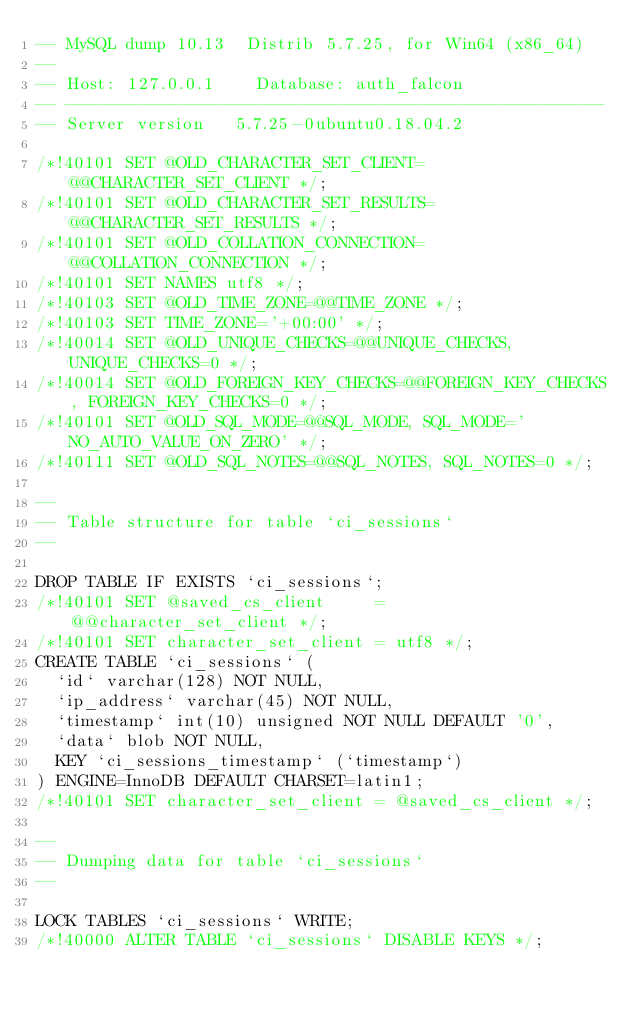Convert code to text. <code><loc_0><loc_0><loc_500><loc_500><_SQL_>-- MySQL dump 10.13  Distrib 5.7.25, for Win64 (x86_64)
--
-- Host: 127.0.0.1    Database: auth_falcon
-- ------------------------------------------------------
-- Server version	5.7.25-0ubuntu0.18.04.2

/*!40101 SET @OLD_CHARACTER_SET_CLIENT=@@CHARACTER_SET_CLIENT */;
/*!40101 SET @OLD_CHARACTER_SET_RESULTS=@@CHARACTER_SET_RESULTS */;
/*!40101 SET @OLD_COLLATION_CONNECTION=@@COLLATION_CONNECTION */;
/*!40101 SET NAMES utf8 */;
/*!40103 SET @OLD_TIME_ZONE=@@TIME_ZONE */;
/*!40103 SET TIME_ZONE='+00:00' */;
/*!40014 SET @OLD_UNIQUE_CHECKS=@@UNIQUE_CHECKS, UNIQUE_CHECKS=0 */;
/*!40014 SET @OLD_FOREIGN_KEY_CHECKS=@@FOREIGN_KEY_CHECKS, FOREIGN_KEY_CHECKS=0 */;
/*!40101 SET @OLD_SQL_MODE=@@SQL_MODE, SQL_MODE='NO_AUTO_VALUE_ON_ZERO' */;
/*!40111 SET @OLD_SQL_NOTES=@@SQL_NOTES, SQL_NOTES=0 */;

--
-- Table structure for table `ci_sessions`
--

DROP TABLE IF EXISTS `ci_sessions`;
/*!40101 SET @saved_cs_client     = @@character_set_client */;
/*!40101 SET character_set_client = utf8 */;
CREATE TABLE `ci_sessions` (
  `id` varchar(128) NOT NULL,
  `ip_address` varchar(45) NOT NULL,
  `timestamp` int(10) unsigned NOT NULL DEFAULT '0',
  `data` blob NOT NULL,
  KEY `ci_sessions_timestamp` (`timestamp`)
) ENGINE=InnoDB DEFAULT CHARSET=latin1;
/*!40101 SET character_set_client = @saved_cs_client */;

--
-- Dumping data for table `ci_sessions`
--

LOCK TABLES `ci_sessions` WRITE;
/*!40000 ALTER TABLE `ci_sessions` DISABLE KEYS */;</code> 